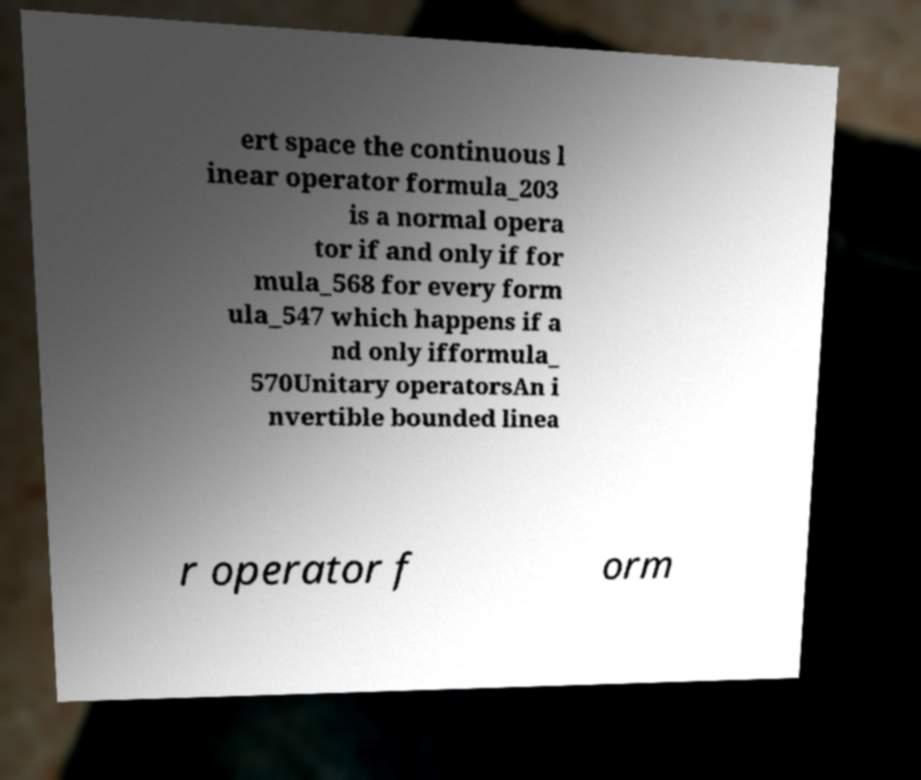Could you assist in decoding the text presented in this image and type it out clearly? ert space the continuous l inear operator formula_203 is a normal opera tor if and only if for mula_568 for every form ula_547 which happens if a nd only ifformula_ 570Unitary operatorsAn i nvertible bounded linea r operator f orm 